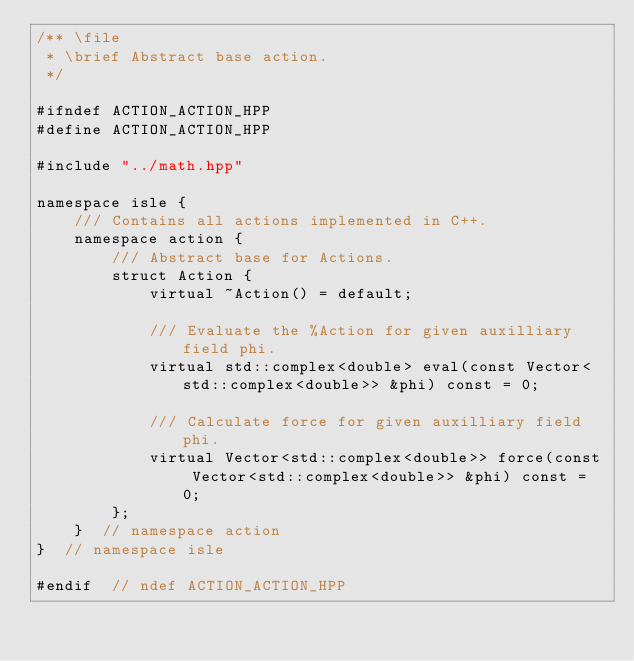Convert code to text. <code><loc_0><loc_0><loc_500><loc_500><_C++_>/** \file
 * \brief Abstract base action.
 */

#ifndef ACTION_ACTION_HPP
#define ACTION_ACTION_HPP

#include "../math.hpp"

namespace isle {
    /// Contains all actions implemented in C++.
    namespace action {
        /// Abstract base for Actions.
        struct Action {
            virtual ~Action() = default;

            /// Evaluate the %Action for given auxilliary field phi.
            virtual std::complex<double> eval(const Vector<std::complex<double>> &phi) const = 0;

            /// Calculate force for given auxilliary field phi.
            virtual Vector<std::complex<double>> force(const Vector<std::complex<double>> &phi) const = 0;
        };
    }  // namespace action
}  // namespace isle

#endif  // ndef ACTION_ACTION_HPP
</code> 